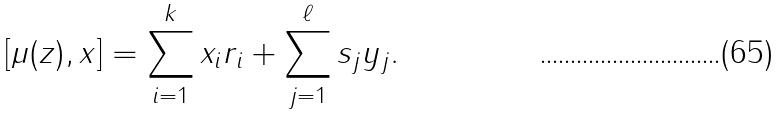Convert formula to latex. <formula><loc_0><loc_0><loc_500><loc_500>[ \mu ( z ) , x ] = \sum _ { i = 1 } ^ { k } x _ { i } r _ { i } + \sum _ { j = 1 } ^ { \ell } s _ { j } y _ { j } .</formula> 